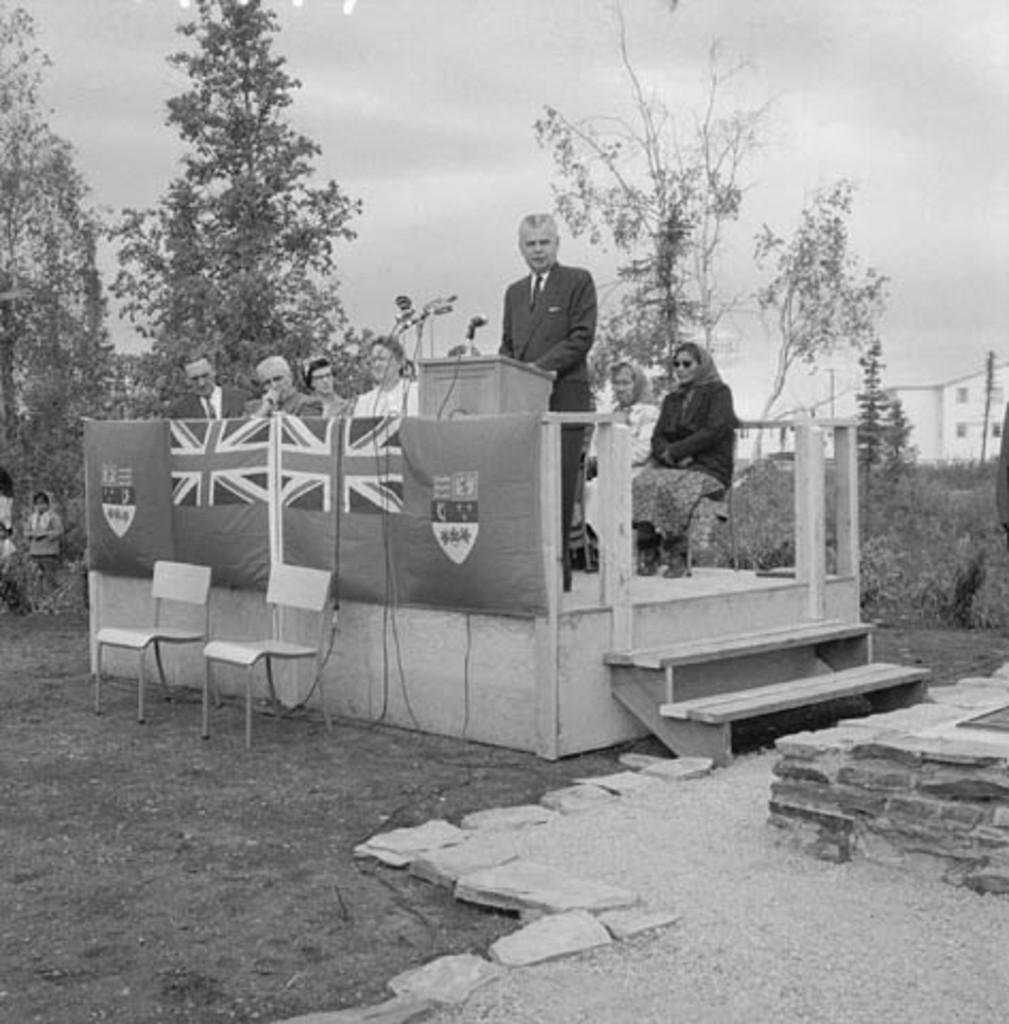Could you give a brief overview of what you see in this image? This is a black and white picture. I can see a man standing near the podium, there are mice, there are group of people sitting on the chairs, there are few people standing, there are flags, stairs, there are plants, trees, there is a building, and in the background there is the sky. 